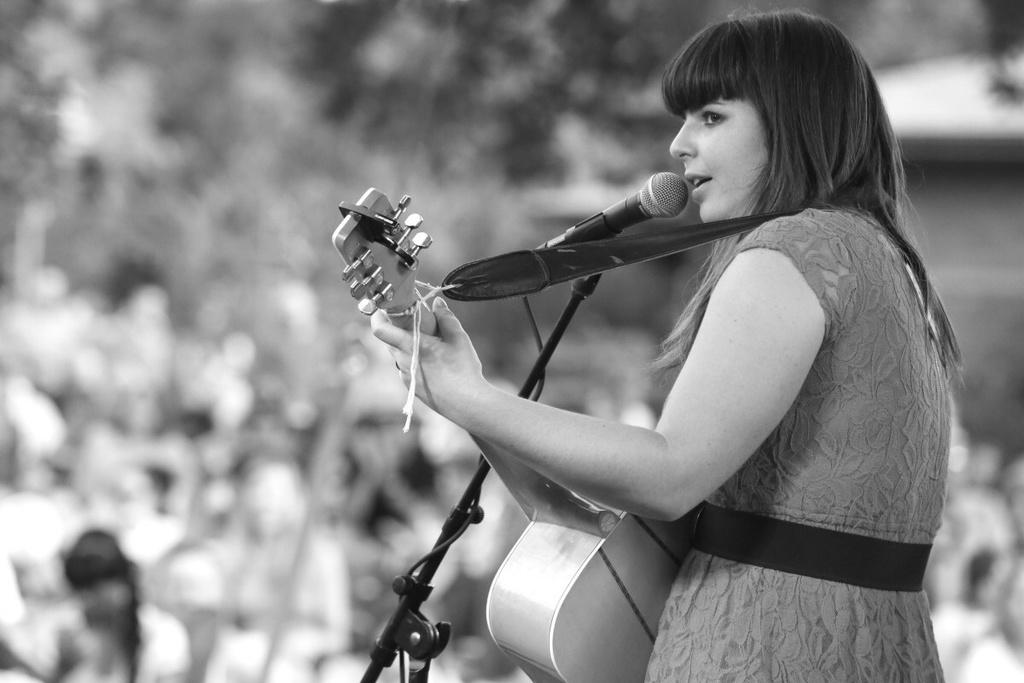What is the woman in the image doing? The woman is singing a song. What is the woman holding in the image? The woman is holding a microphone and a guitar. What type of jeans is the woman wearing in the image? The facts provided do not mention any clothing, including jeans, so we cannot determine what type of jeans the woman is wearing. 